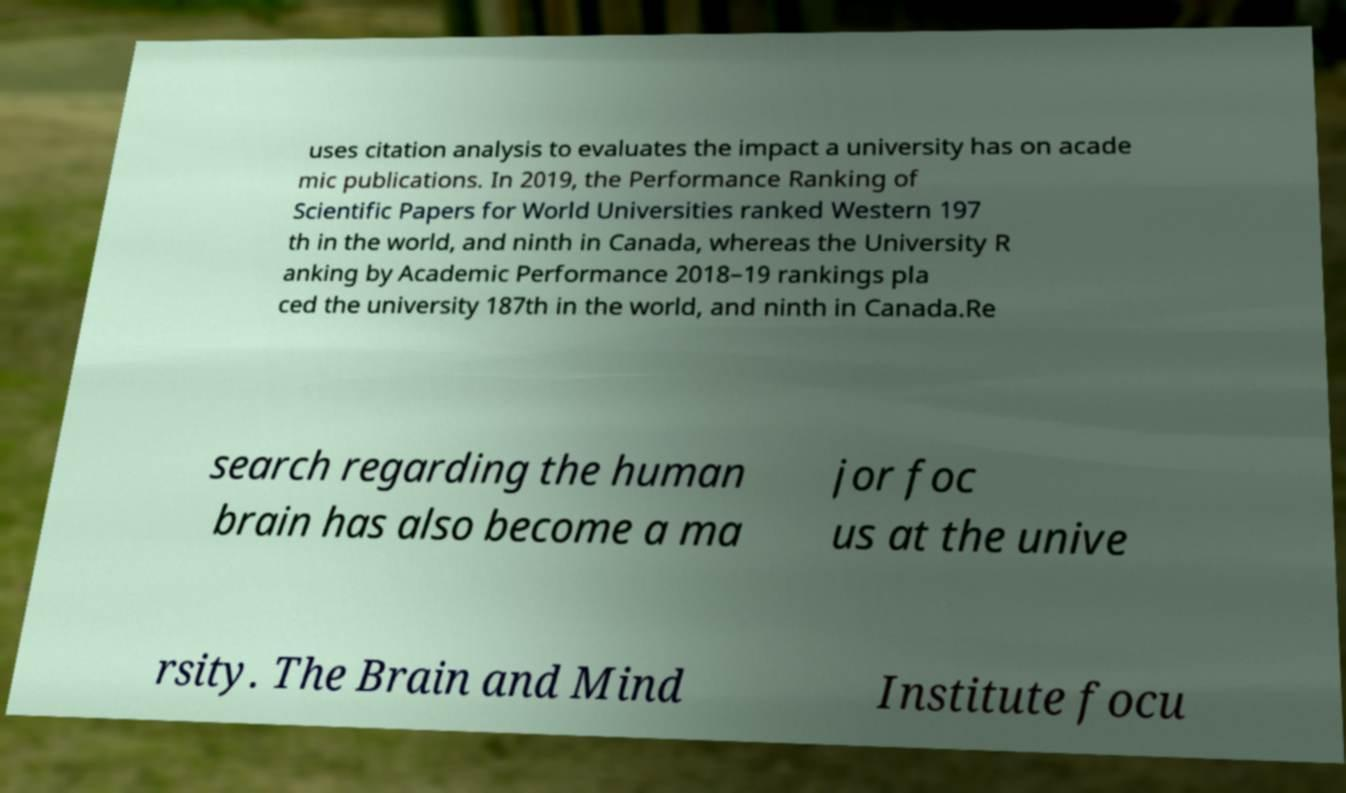For documentation purposes, I need the text within this image transcribed. Could you provide that? uses citation analysis to evaluates the impact a university has on acade mic publications. In 2019, the Performance Ranking of Scientific Papers for World Universities ranked Western 197 th in the world, and ninth in Canada, whereas the University R anking by Academic Performance 2018–19 rankings pla ced the university 187th in the world, and ninth in Canada.Re search regarding the human brain has also become a ma jor foc us at the unive rsity. The Brain and Mind Institute focu 